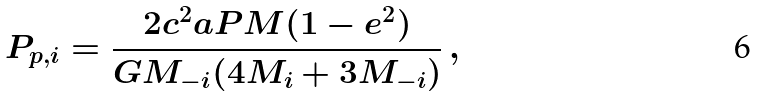Convert formula to latex. <formula><loc_0><loc_0><loc_500><loc_500>P _ { p , i } = \frac { 2 c ^ { 2 } a P M ( 1 - e ^ { 2 } ) } { G M _ { - i } ( 4 M _ { i } + 3 M _ { - i } ) } \, ,</formula> 